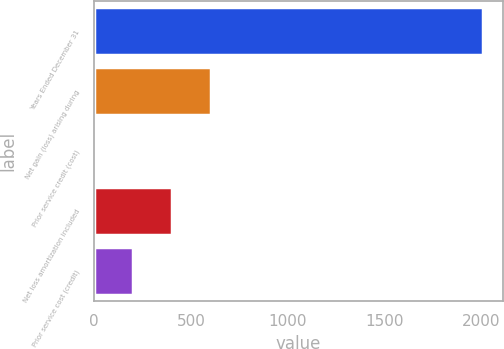Convert chart to OTSL. <chart><loc_0><loc_0><loc_500><loc_500><bar_chart><fcel>Years Ended December 31<fcel>Net gain (loss) arising during<fcel>Prior service credit (cost)<fcel>Net loss amortization included<fcel>Prior service cost (credit)<nl><fcel>2010<fcel>603.7<fcel>1<fcel>402.8<fcel>201.9<nl></chart> 